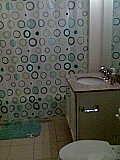How many people are in the shower?
Give a very brief answer. 0. How many rugs are in the bathroom?
Give a very brief answer. 1. How many people are waiting?
Give a very brief answer. 0. 